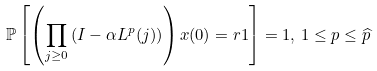<formula> <loc_0><loc_0><loc_500><loc_500>\mathbb { P } \left [ \left ( \prod _ { j \geq 0 } \left ( I - \alpha L ^ { p } ( j ) \right ) \right ) x ( 0 ) = r 1 \right ] = 1 , \, 1 \leq p \leq \widehat { p }</formula> 